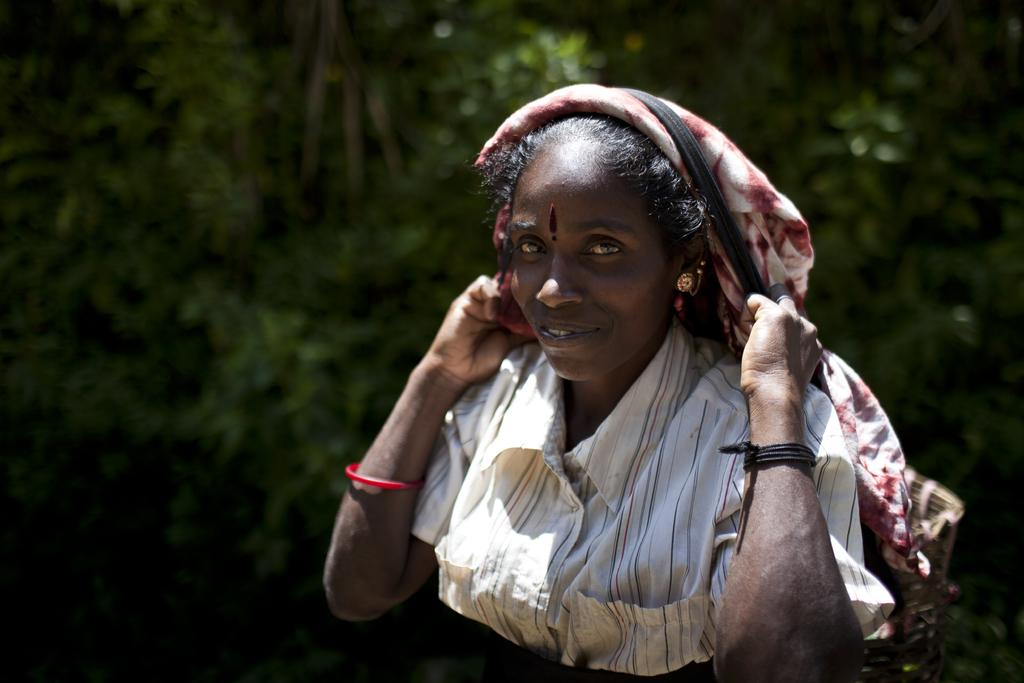Who is present in the image? There is a woman in the image. What is the woman wearing? The woman is wearing a white dress. What can be seen in the background of the image? There are trees in the background of the image. What type of soda is the woman holding in the image? There is no soda present in the image; the woman is not holding any beverage. 